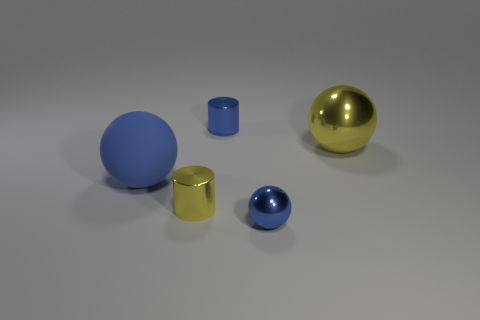Are any cylinders visible?
Keep it short and to the point. Yes. How many things are either rubber balls or big things that are behind the blue matte object?
Ensure brevity in your answer.  2. There is a yellow thing that is behind the matte thing; is it the same size as the large blue matte sphere?
Keep it short and to the point. Yes. What number of other things are the same size as the yellow cylinder?
Your response must be concise. 2. The rubber thing has what color?
Your answer should be compact. Blue. What material is the tiny cylinder in front of the blue cylinder?
Offer a very short reply. Metal. Are there the same number of tiny blue cylinders that are on the left side of the blue metal cylinder and big purple metal spheres?
Your response must be concise. Yes. Do the big shiny thing and the small yellow metal object have the same shape?
Your answer should be very brief. No. Is there anything else that has the same color as the rubber thing?
Your response must be concise. Yes. There is a blue thing that is both behind the tiny yellow shiny cylinder and right of the big rubber ball; what shape is it?
Offer a terse response. Cylinder. 